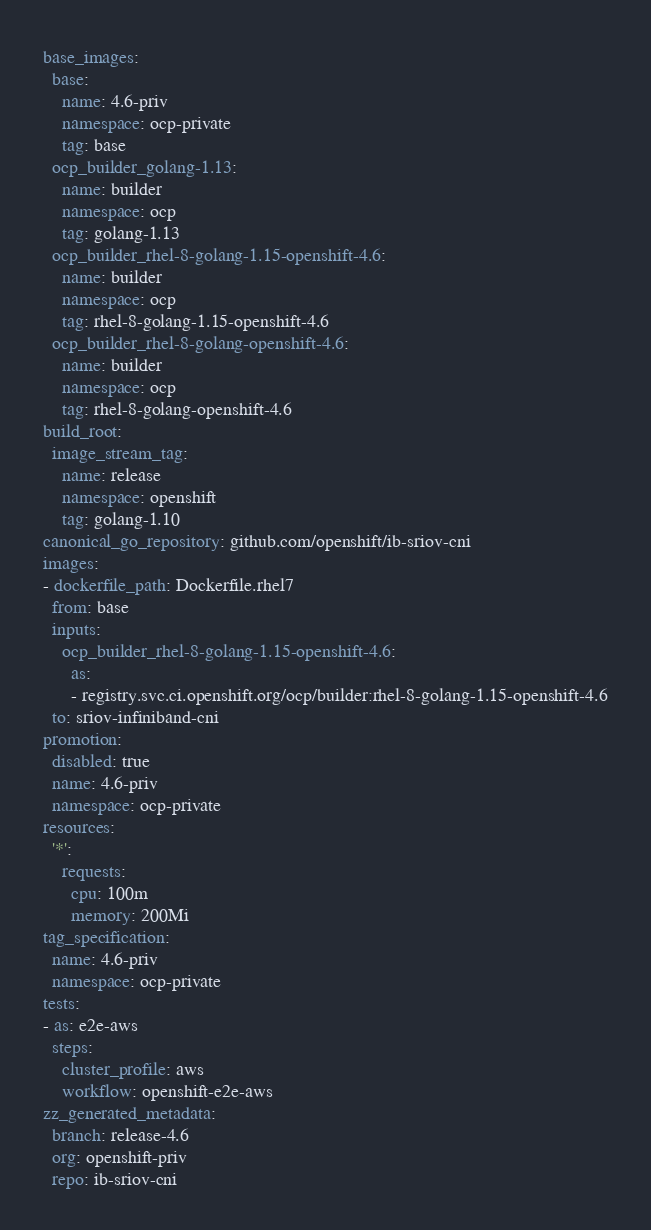<code> <loc_0><loc_0><loc_500><loc_500><_YAML_>base_images:
  base:
    name: 4.6-priv
    namespace: ocp-private
    tag: base
  ocp_builder_golang-1.13:
    name: builder
    namespace: ocp
    tag: golang-1.13
  ocp_builder_rhel-8-golang-1.15-openshift-4.6:
    name: builder
    namespace: ocp
    tag: rhel-8-golang-1.15-openshift-4.6
  ocp_builder_rhel-8-golang-openshift-4.6:
    name: builder
    namespace: ocp
    tag: rhel-8-golang-openshift-4.6
build_root:
  image_stream_tag:
    name: release
    namespace: openshift
    tag: golang-1.10
canonical_go_repository: github.com/openshift/ib-sriov-cni
images:
- dockerfile_path: Dockerfile.rhel7
  from: base
  inputs:
    ocp_builder_rhel-8-golang-1.15-openshift-4.6:
      as:
      - registry.svc.ci.openshift.org/ocp/builder:rhel-8-golang-1.15-openshift-4.6
  to: sriov-infiniband-cni
promotion:
  disabled: true
  name: 4.6-priv
  namespace: ocp-private
resources:
  '*':
    requests:
      cpu: 100m
      memory: 200Mi
tag_specification:
  name: 4.6-priv
  namespace: ocp-private
tests:
- as: e2e-aws
  steps:
    cluster_profile: aws
    workflow: openshift-e2e-aws
zz_generated_metadata:
  branch: release-4.6
  org: openshift-priv
  repo: ib-sriov-cni
</code> 